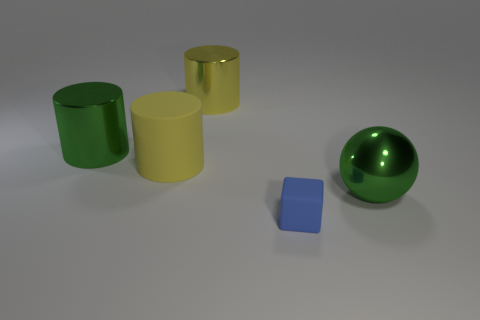What shape is the thing that is in front of the yellow rubber cylinder and on the left side of the large green metallic sphere?
Your response must be concise. Cube. There is a matte thing on the right side of the yellow metal cylinder; how big is it?
Provide a succinct answer. Small. Do the shiny cylinder on the left side of the big yellow matte thing and the tiny thing have the same color?
Provide a succinct answer. No. How many other blue things have the same shape as the blue object?
Provide a succinct answer. 0. What number of objects are either objects to the left of the yellow shiny thing or objects that are behind the small blue matte block?
Your answer should be very brief. 4. How many blue things are either tiny matte blocks or metallic cylinders?
Offer a very short reply. 1. What material is the large thing that is to the right of the big yellow matte cylinder and left of the tiny object?
Your answer should be very brief. Metal. Is the material of the blue thing the same as the green sphere?
Keep it short and to the point. No. What number of shiny objects are the same size as the block?
Offer a very short reply. 0. Are there an equal number of large yellow rubber objects that are to the right of the green metallic ball and yellow cylinders?
Your answer should be compact. No. 